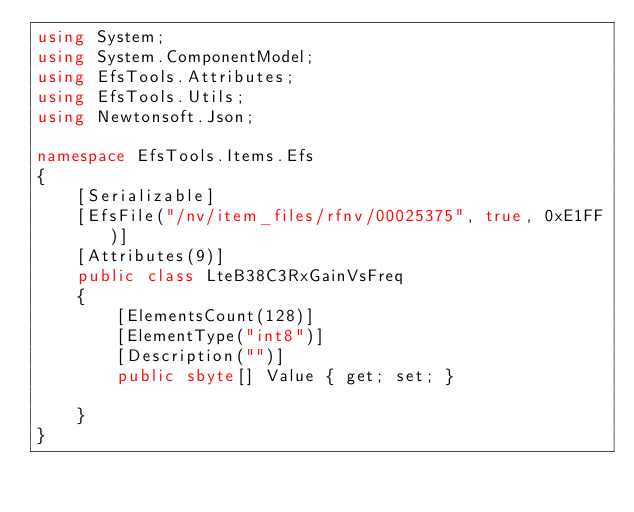<code> <loc_0><loc_0><loc_500><loc_500><_C#_>using System;
using System.ComponentModel;
using EfsTools.Attributes;
using EfsTools.Utils;
using Newtonsoft.Json;

namespace EfsTools.Items.Efs
{
    [Serializable]
    [EfsFile("/nv/item_files/rfnv/00025375", true, 0xE1FF)]
    [Attributes(9)]
    public class LteB38C3RxGainVsFreq
    {
        [ElementsCount(128)]
        [ElementType("int8")]
        [Description("")]
        public sbyte[] Value { get; set; }
        
    }
}
</code> 